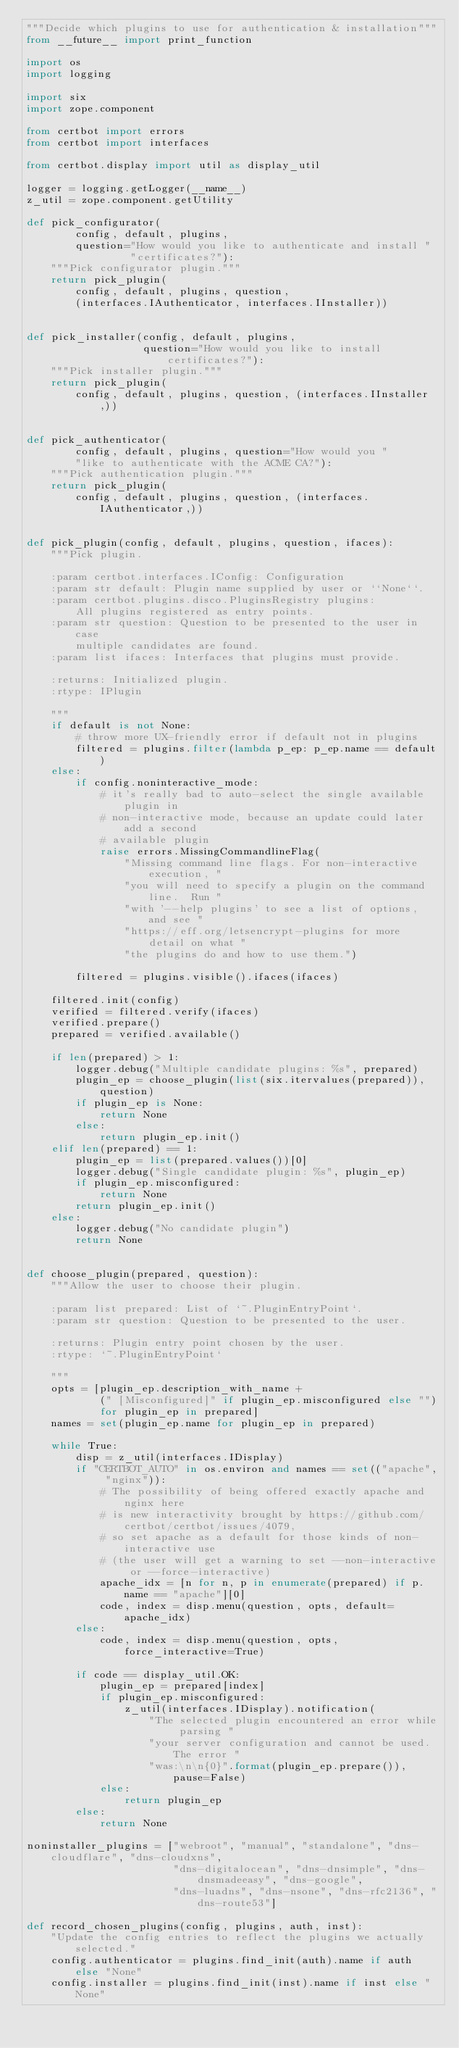Convert code to text. <code><loc_0><loc_0><loc_500><loc_500><_Python_>"""Decide which plugins to use for authentication & installation"""
from __future__ import print_function

import os
import logging

import six
import zope.component

from certbot import errors
from certbot import interfaces

from certbot.display import util as display_util

logger = logging.getLogger(__name__)
z_util = zope.component.getUtility

def pick_configurator(
        config, default, plugins,
        question="How would you like to authenticate and install "
                 "certificates?"):
    """Pick configurator plugin."""
    return pick_plugin(
        config, default, plugins, question,
        (interfaces.IAuthenticator, interfaces.IInstaller))


def pick_installer(config, default, plugins,
                   question="How would you like to install certificates?"):
    """Pick installer plugin."""
    return pick_plugin(
        config, default, plugins, question, (interfaces.IInstaller,))


def pick_authenticator(
        config, default, plugins, question="How would you "
        "like to authenticate with the ACME CA?"):
    """Pick authentication plugin."""
    return pick_plugin(
        config, default, plugins, question, (interfaces.IAuthenticator,))


def pick_plugin(config, default, plugins, question, ifaces):
    """Pick plugin.

    :param certbot.interfaces.IConfig: Configuration
    :param str default: Plugin name supplied by user or ``None``.
    :param certbot.plugins.disco.PluginsRegistry plugins:
        All plugins registered as entry points.
    :param str question: Question to be presented to the user in case
        multiple candidates are found.
    :param list ifaces: Interfaces that plugins must provide.

    :returns: Initialized plugin.
    :rtype: IPlugin

    """
    if default is not None:
        # throw more UX-friendly error if default not in plugins
        filtered = plugins.filter(lambda p_ep: p_ep.name == default)
    else:
        if config.noninteractive_mode:
            # it's really bad to auto-select the single available plugin in
            # non-interactive mode, because an update could later add a second
            # available plugin
            raise errors.MissingCommandlineFlag(
                "Missing command line flags. For non-interactive execution, "
                "you will need to specify a plugin on the command line.  Run "
                "with '--help plugins' to see a list of options, and see "
                "https://eff.org/letsencrypt-plugins for more detail on what "
                "the plugins do and how to use them.")

        filtered = plugins.visible().ifaces(ifaces)

    filtered.init(config)
    verified = filtered.verify(ifaces)
    verified.prepare()
    prepared = verified.available()

    if len(prepared) > 1:
        logger.debug("Multiple candidate plugins: %s", prepared)
        plugin_ep = choose_plugin(list(six.itervalues(prepared)), question)
        if plugin_ep is None:
            return None
        else:
            return plugin_ep.init()
    elif len(prepared) == 1:
        plugin_ep = list(prepared.values())[0]
        logger.debug("Single candidate plugin: %s", plugin_ep)
        if plugin_ep.misconfigured:
            return None
        return plugin_ep.init()
    else:
        logger.debug("No candidate plugin")
        return None


def choose_plugin(prepared, question):
    """Allow the user to choose their plugin.

    :param list prepared: List of `~.PluginEntryPoint`.
    :param str question: Question to be presented to the user.

    :returns: Plugin entry point chosen by the user.
    :rtype: `~.PluginEntryPoint`

    """
    opts = [plugin_ep.description_with_name +
            (" [Misconfigured]" if plugin_ep.misconfigured else "")
            for plugin_ep in prepared]
    names = set(plugin_ep.name for plugin_ep in prepared)

    while True:
        disp = z_util(interfaces.IDisplay)
        if "CERTBOT_AUTO" in os.environ and names == set(("apache", "nginx")):
            # The possibility of being offered exactly apache and nginx here
            # is new interactivity brought by https://github.com/certbot/certbot/issues/4079,
            # so set apache as a default for those kinds of non-interactive use
            # (the user will get a warning to set --non-interactive or --force-interactive)
            apache_idx = [n for n, p in enumerate(prepared) if p.name == "apache"][0]
            code, index = disp.menu(question, opts, default=apache_idx)
        else:
            code, index = disp.menu(question, opts, force_interactive=True)

        if code == display_util.OK:
            plugin_ep = prepared[index]
            if plugin_ep.misconfigured:
                z_util(interfaces.IDisplay).notification(
                    "The selected plugin encountered an error while parsing "
                    "your server configuration and cannot be used. The error "
                    "was:\n\n{0}".format(plugin_ep.prepare()), pause=False)
            else:
                return plugin_ep
        else:
            return None

noninstaller_plugins = ["webroot", "manual", "standalone", "dns-cloudflare", "dns-cloudxns",
                        "dns-digitalocean", "dns-dnsimple", "dns-dnsmadeeasy", "dns-google",
                        "dns-luadns", "dns-nsone", "dns-rfc2136", "dns-route53"]

def record_chosen_plugins(config, plugins, auth, inst):
    "Update the config entries to reflect the plugins we actually selected."
    config.authenticator = plugins.find_init(auth).name if auth else "None"
    config.installer = plugins.find_init(inst).name if inst else "None"</code> 